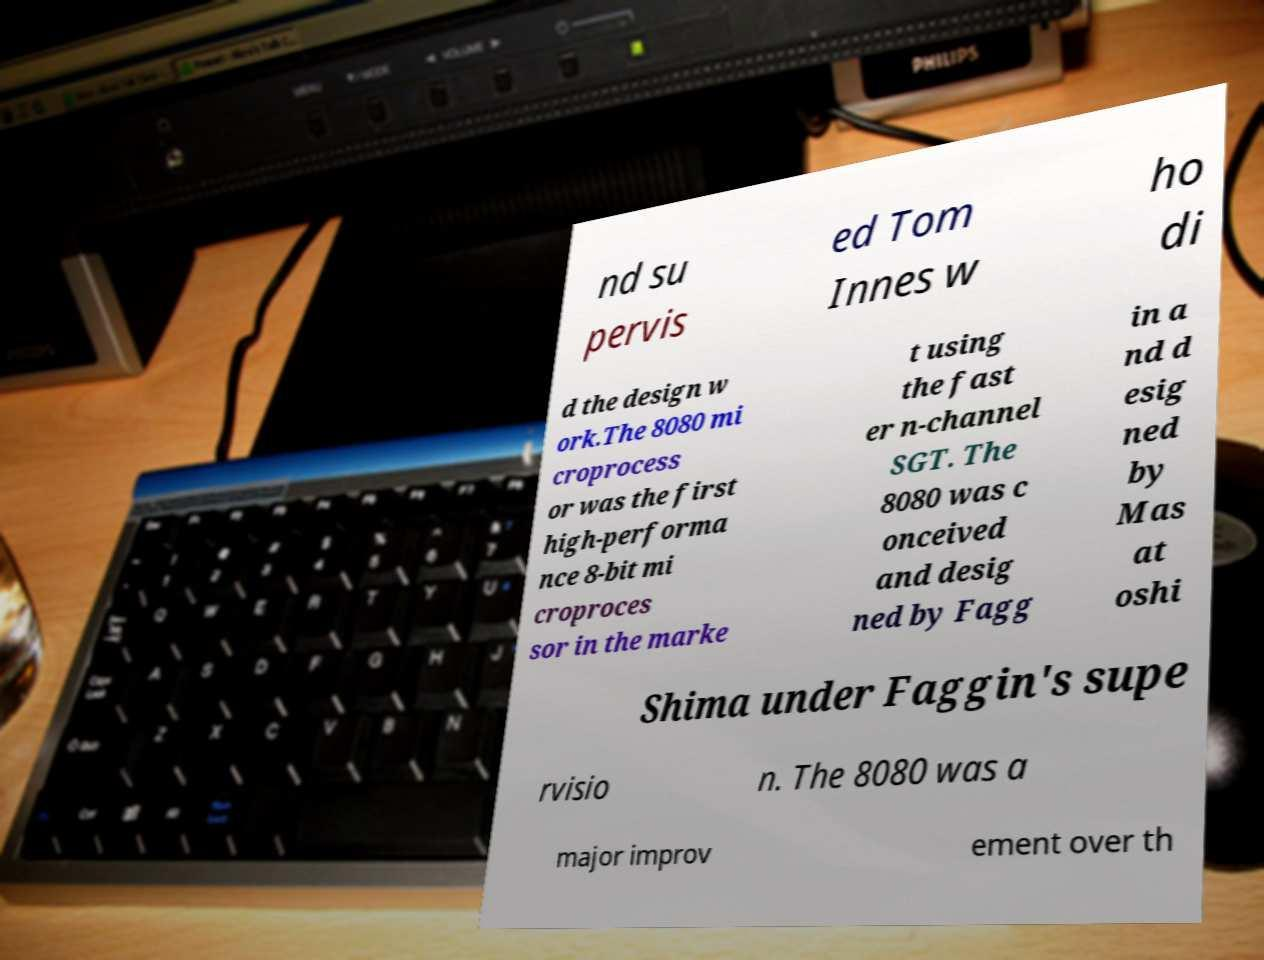What messages or text are displayed in this image? I need them in a readable, typed format. nd su pervis ed Tom Innes w ho di d the design w ork.The 8080 mi croprocess or was the first high-performa nce 8-bit mi croproces sor in the marke t using the fast er n-channel SGT. The 8080 was c onceived and desig ned by Fagg in a nd d esig ned by Mas at oshi Shima under Faggin's supe rvisio n. The 8080 was a major improv ement over th 